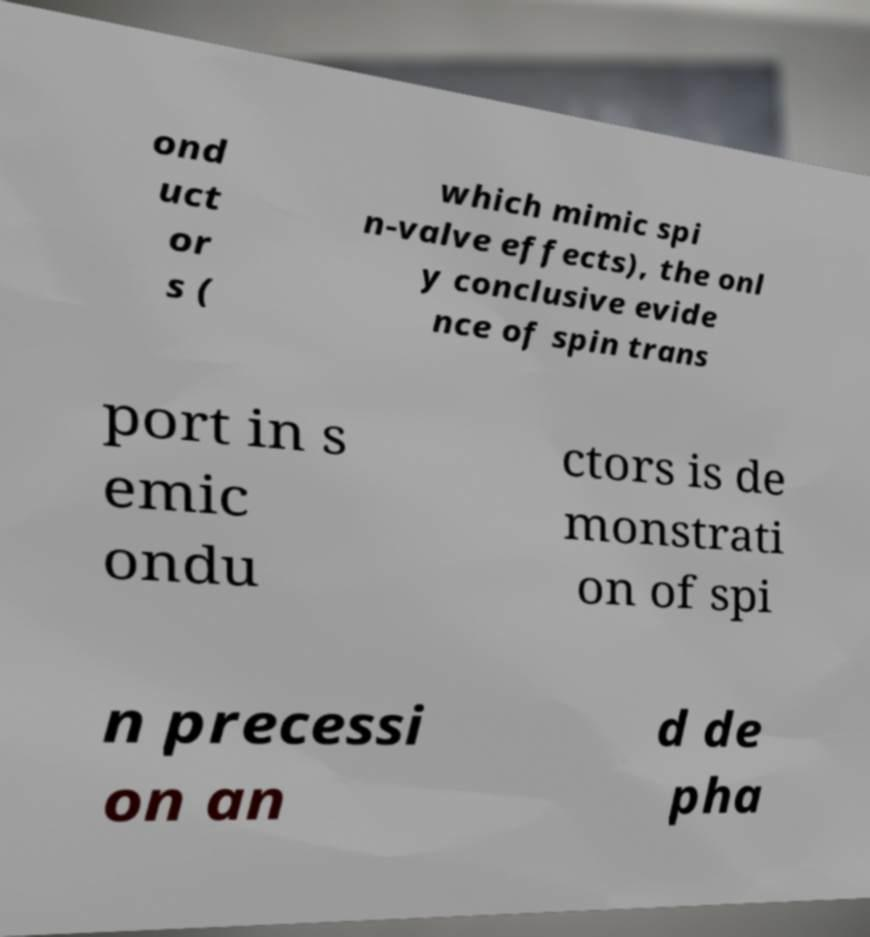What messages or text are displayed in this image? I need them in a readable, typed format. ond uct or s ( which mimic spi n-valve effects), the onl y conclusive evide nce of spin trans port in s emic ondu ctors is de monstrati on of spi n precessi on an d de pha 